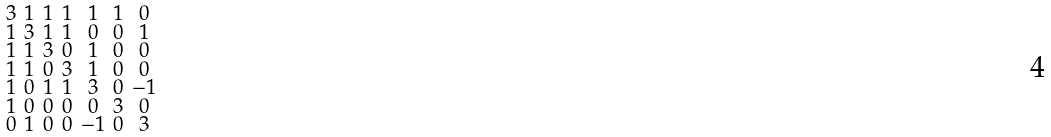Convert formula to latex. <formula><loc_0><loc_0><loc_500><loc_500>\begin{smallmatrix} 3 & 1 & 1 & 1 & 1 & 1 & 0 \\ 1 & 3 & 1 & 1 & 0 & 0 & 1 \\ 1 & 1 & 3 & 0 & 1 & 0 & 0 \\ 1 & 1 & 0 & 3 & 1 & 0 & 0 \\ 1 & 0 & 1 & 1 & 3 & 0 & - 1 \\ 1 & 0 & 0 & 0 & 0 & 3 & 0 \\ 0 & 1 & 0 & 0 & - 1 & 0 & 3 \end{smallmatrix}</formula> 